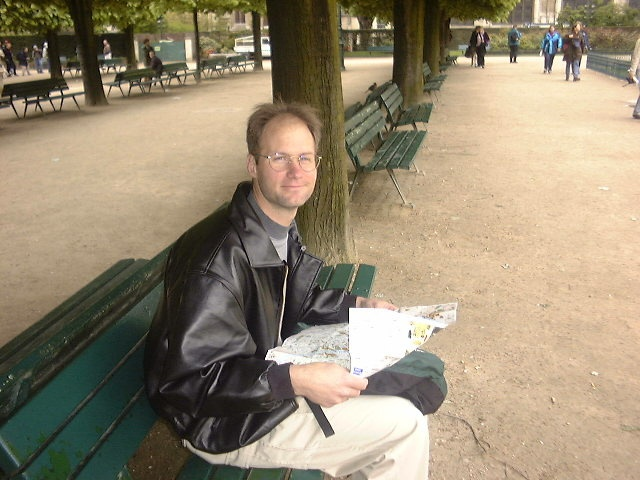Describe the objects in this image and their specific colors. I can see people in black, gray, ivory, and tan tones, bench in black, darkgreen, teal, and gray tones, bench in black, gray, and darkgreen tones, backpack in black and gray tones, and bench in black, gray, and tan tones in this image. 